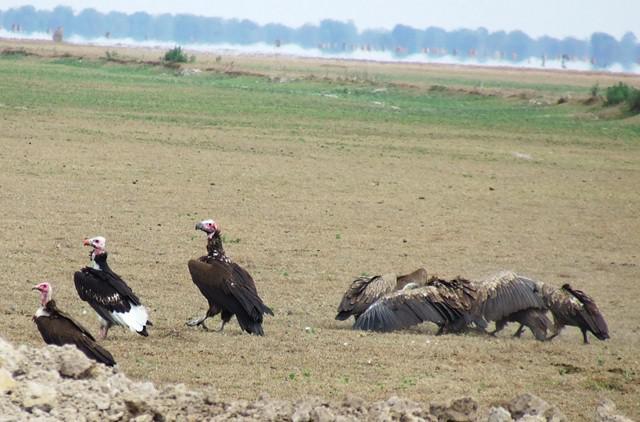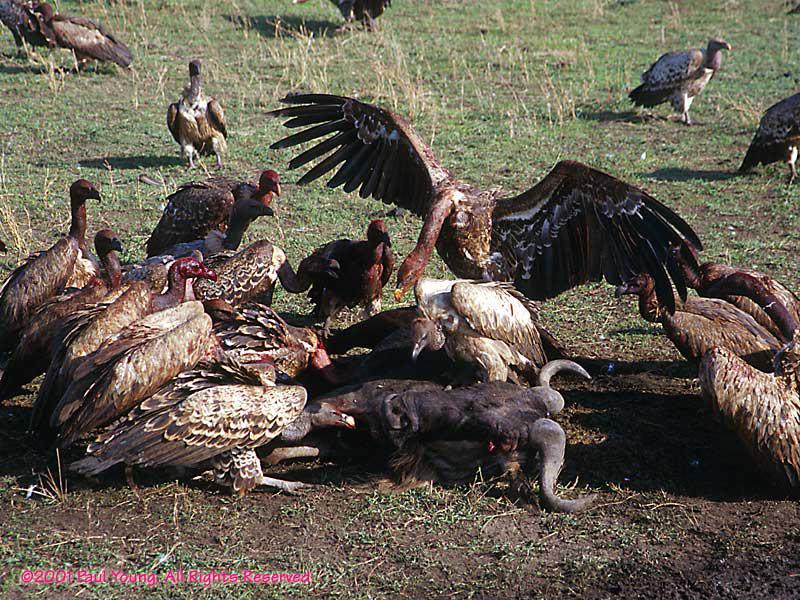The first image is the image on the left, the second image is the image on the right. Examine the images to the left and right. Is the description "An image shows a group of vultures perched on something that is elevated." accurate? Answer yes or no. No. The first image is the image on the left, the second image is the image on the right. Examine the images to the left and right. Is the description "A single bird is landing with its wings spread in the image on the right." accurate? Answer yes or no. Yes. 